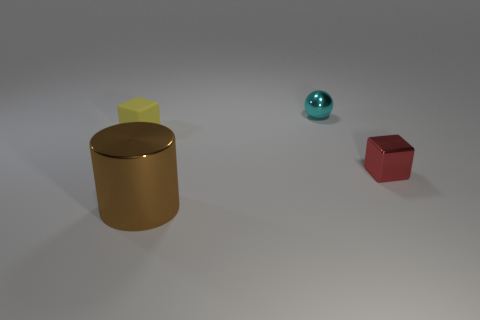Add 1 cyan balls. How many objects exist? 5 Subtract all balls. How many objects are left? 3 Subtract 0 green cylinders. How many objects are left? 4 Subtract all small red cylinders. Subtract all big brown cylinders. How many objects are left? 3 Add 4 red cubes. How many red cubes are left? 5 Add 4 small purple matte cubes. How many small purple matte cubes exist? 4 